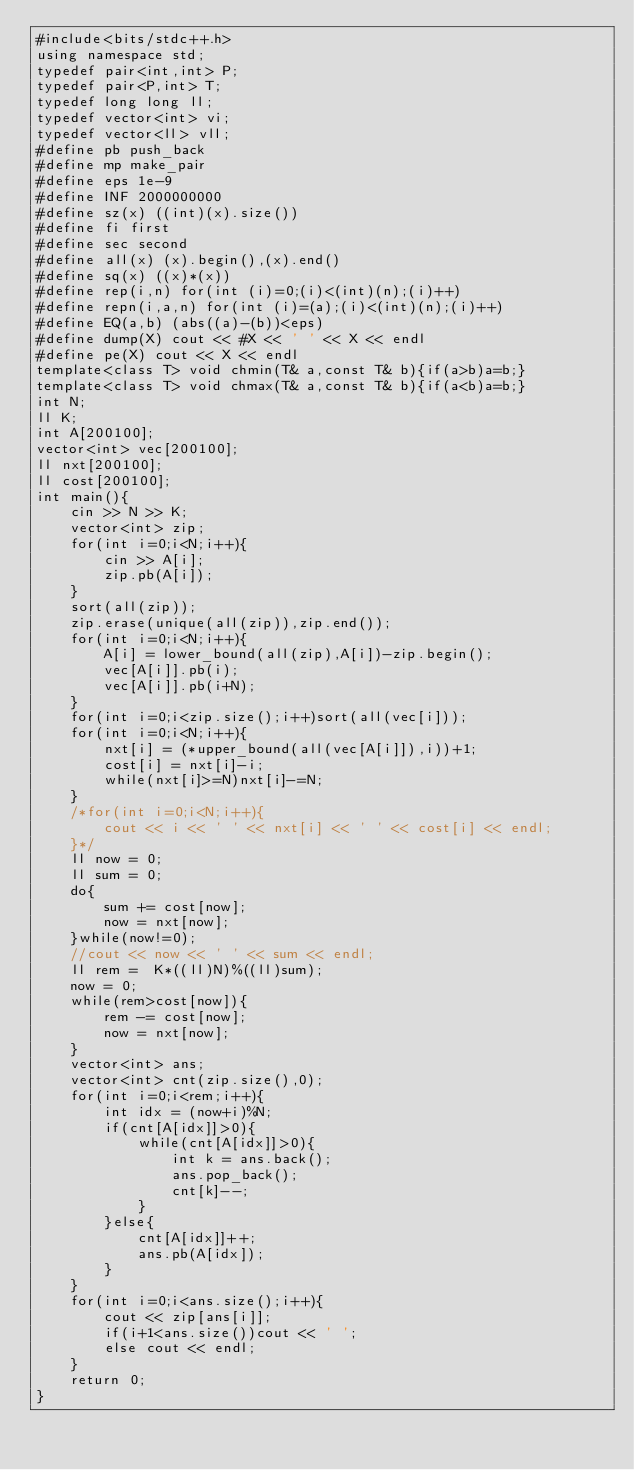<code> <loc_0><loc_0><loc_500><loc_500><_C++_>#include<bits/stdc++.h>
using namespace std;
typedef pair<int,int> P;
typedef pair<P,int> T;
typedef long long ll;
typedef vector<int> vi;
typedef vector<ll> vll;
#define pb push_back
#define mp make_pair
#define eps 1e-9
#define INF 2000000000
#define sz(x) ((int)(x).size())
#define fi first
#define sec second
#define all(x) (x).begin(),(x).end()
#define sq(x) ((x)*(x))
#define rep(i,n) for(int (i)=0;(i)<(int)(n);(i)++)
#define repn(i,a,n) for(int (i)=(a);(i)<(int)(n);(i)++)
#define EQ(a,b) (abs((a)-(b))<eps)
#define dump(X) cout << #X << ' ' << X << endl
#define pe(X) cout << X << endl
template<class T> void chmin(T& a,const T& b){if(a>b)a=b;}
template<class T> void chmax(T& a,const T& b){if(a<b)a=b;}
int N;
ll K;
int A[200100];
vector<int> vec[200100];
ll nxt[200100];
ll cost[200100];
int main(){
	cin >> N >> K;
	vector<int> zip;
	for(int i=0;i<N;i++){
		cin >> A[i];
		zip.pb(A[i]);
	}
	sort(all(zip));
	zip.erase(unique(all(zip)),zip.end());
	for(int i=0;i<N;i++){
		A[i] = lower_bound(all(zip),A[i])-zip.begin();
		vec[A[i]].pb(i);
		vec[A[i]].pb(i+N);
	}
	for(int i=0;i<zip.size();i++)sort(all(vec[i]));
	for(int i=0;i<N;i++){
		nxt[i] = (*upper_bound(all(vec[A[i]]),i))+1;
		cost[i] = nxt[i]-i;
		while(nxt[i]>=N)nxt[i]-=N;
	}
	/*for(int i=0;i<N;i++){
		cout << i << ' ' << nxt[i] << ' ' << cost[i] << endl; 
	}*/
	ll now = 0;
	ll sum = 0;
	do{
		sum += cost[now];
		now = nxt[now];
	}while(now!=0);
	//cout << now << ' ' << sum << endl;
	ll rem =  K*((ll)N)%((ll)sum);
	now = 0;
	while(rem>cost[now]){
		rem -= cost[now];
		now = nxt[now]; 
	}
	vector<int> ans;
	vector<int> cnt(zip.size(),0);
	for(int i=0;i<rem;i++){
		int idx = (now+i)%N;
		if(cnt[A[idx]]>0){
			while(cnt[A[idx]]>0){
				int k = ans.back();
				ans.pop_back();
				cnt[k]--;
			}
		}else{
			cnt[A[idx]]++;
			ans.pb(A[idx]);
		}
	}
	for(int i=0;i<ans.size();i++){
		cout << zip[ans[i]];
		if(i+1<ans.size())cout << ' ';
		else cout << endl;
	}
	return 0;
}</code> 